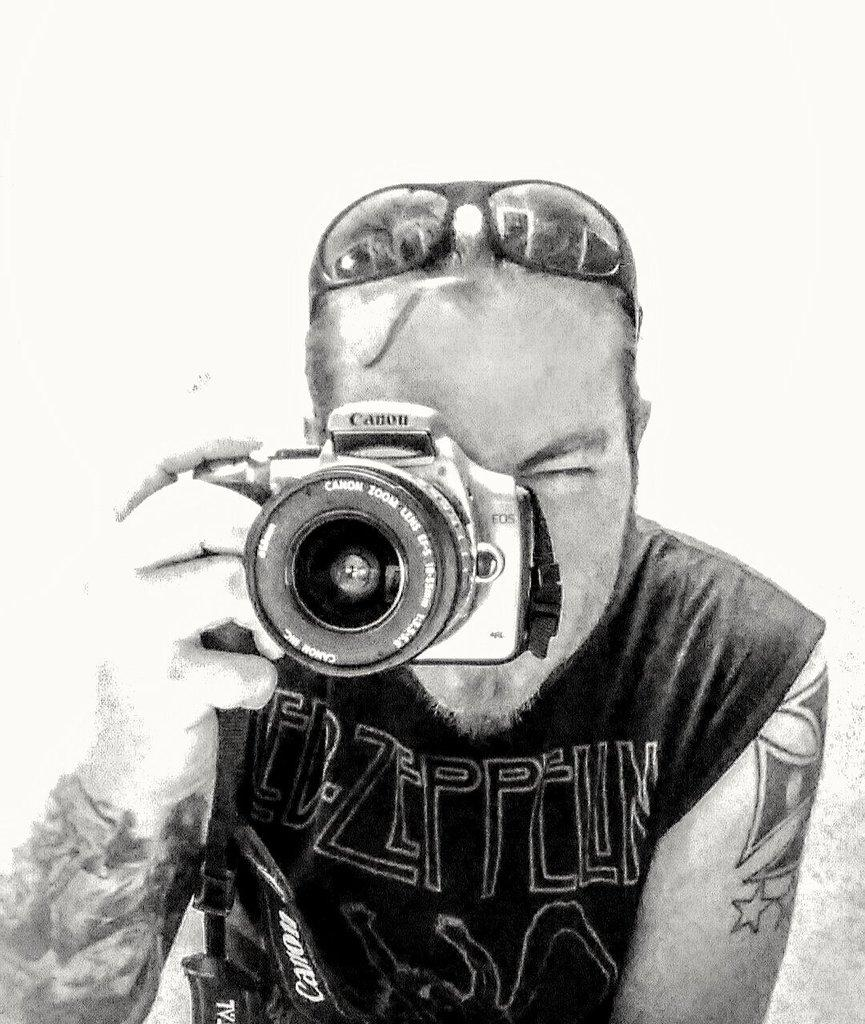Who is the main subject in the image? There is a man in the image. What is the man wearing? The man is wearing goggles. What is the man holding in the image? The man is holding a camera. What is the man doing with the camera? The man is taking a picture. What type of sticks can be seen in the image? There are no sticks present in the image. How does the dust affect the man's ability to take a picture in the image? There is no dust present in the image, so it does not affect the man's ability to take a picture. 